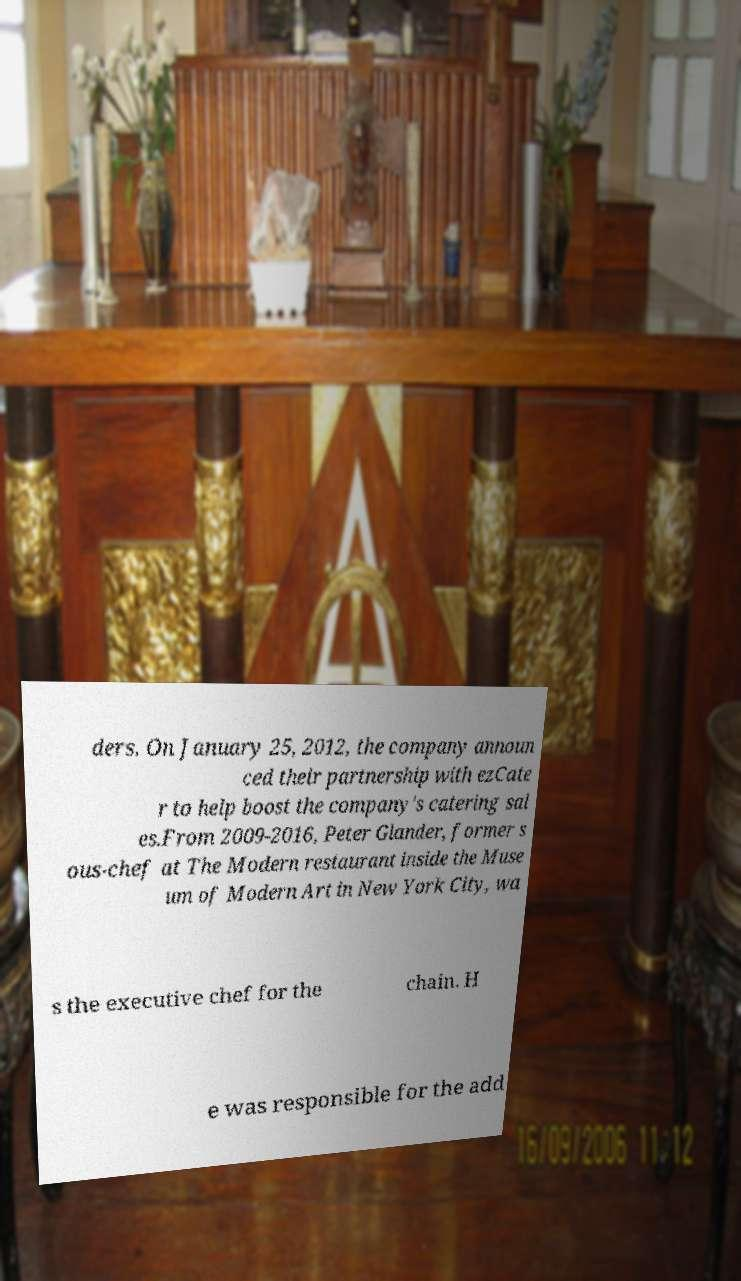I need the written content from this picture converted into text. Can you do that? ders. On January 25, 2012, the company announ ced their partnership with ezCate r to help boost the company's catering sal es.From 2009-2016, Peter Glander, former s ous-chef at The Modern restaurant inside the Muse um of Modern Art in New York City, wa s the executive chef for the chain. H e was responsible for the add 